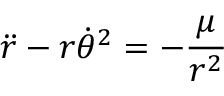Convert formula to latex. <formula><loc_0><loc_0><loc_500><loc_500>{ \ddot { r } } - r { \dot { \theta } } ^ { 2 } = - { \frac { \mu } { r ^ { 2 } } }</formula> 